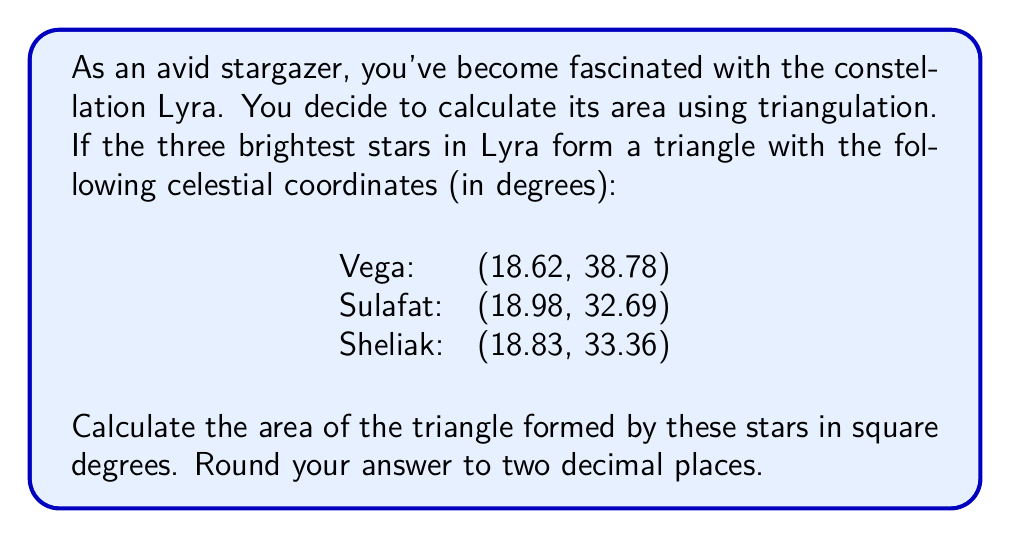Help me with this question. To solve this problem, we'll use the following steps:

1. Convert the celestial coordinates to Cartesian coordinates.
2. Calculate the distances between the stars using the distance formula.
3. Use Heron's formula to calculate the area of the triangle.

Step 1: Convert celestial coordinates to Cartesian coordinates
We can treat the right ascension (RA) as x and declination (Dec) as y:

Vega: (18.62, 38.78)
Sulafat: (18.98, 32.69)
Sheliak: (18.83, 33.36)

Step 2: Calculate the distances between the stars
We'll use the distance formula: $d = \sqrt{(x_2-x_1)^2 + (y_2-y_1)^2}$

a) Distance between Vega and Sulafat:
$$d_{VS} = \sqrt{(18.98-18.62)^2 + (32.69-38.78)^2} = 6.1458$$

b) Distance between Sulafat and Sheliak:
$$d_{SS} = \sqrt{(18.83-18.98)^2 + (33.36-32.69)^2} = 0.7494$$

c) Distance between Sheliak and Vega:
$$d_{SV} = \sqrt{(18.62-18.83)^2 + (38.78-33.36)^2} = 5.4373$$

Step 3: Use Heron's formula to calculate the area
Heron's formula: $A = \sqrt{s(s-a)(s-b)(s-c)}$
where $s = \frac{a+b+c}{2}$ (semi-perimeter)

First, calculate s:
$$s = \frac{6.1458 + 0.7494 + 5.4373}{2} = 6.1663$$

Now, apply Heron's formula:
$$A = \sqrt{6.1663(6.1663-6.1458)(6.1663-0.7494)(6.1663-5.4373)}$$
$$A = \sqrt{6.1663 \cdot 0.0205 \cdot 5.4169 \cdot 0.7290}$$
$$A = \sqrt{0.4999} = 0.7071$$

Therefore, the area of the triangle is approximately 0.71 square degrees.
Answer: 0.71 square degrees 